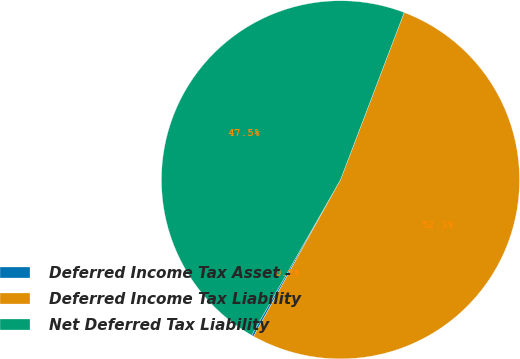Convert chart to OTSL. <chart><loc_0><loc_0><loc_500><loc_500><pie_chart><fcel>Deferred Income Tax Asset -<fcel>Deferred Income Tax Liability<fcel>Net Deferred Tax Liability<nl><fcel>0.2%<fcel>52.27%<fcel>47.52%<nl></chart> 